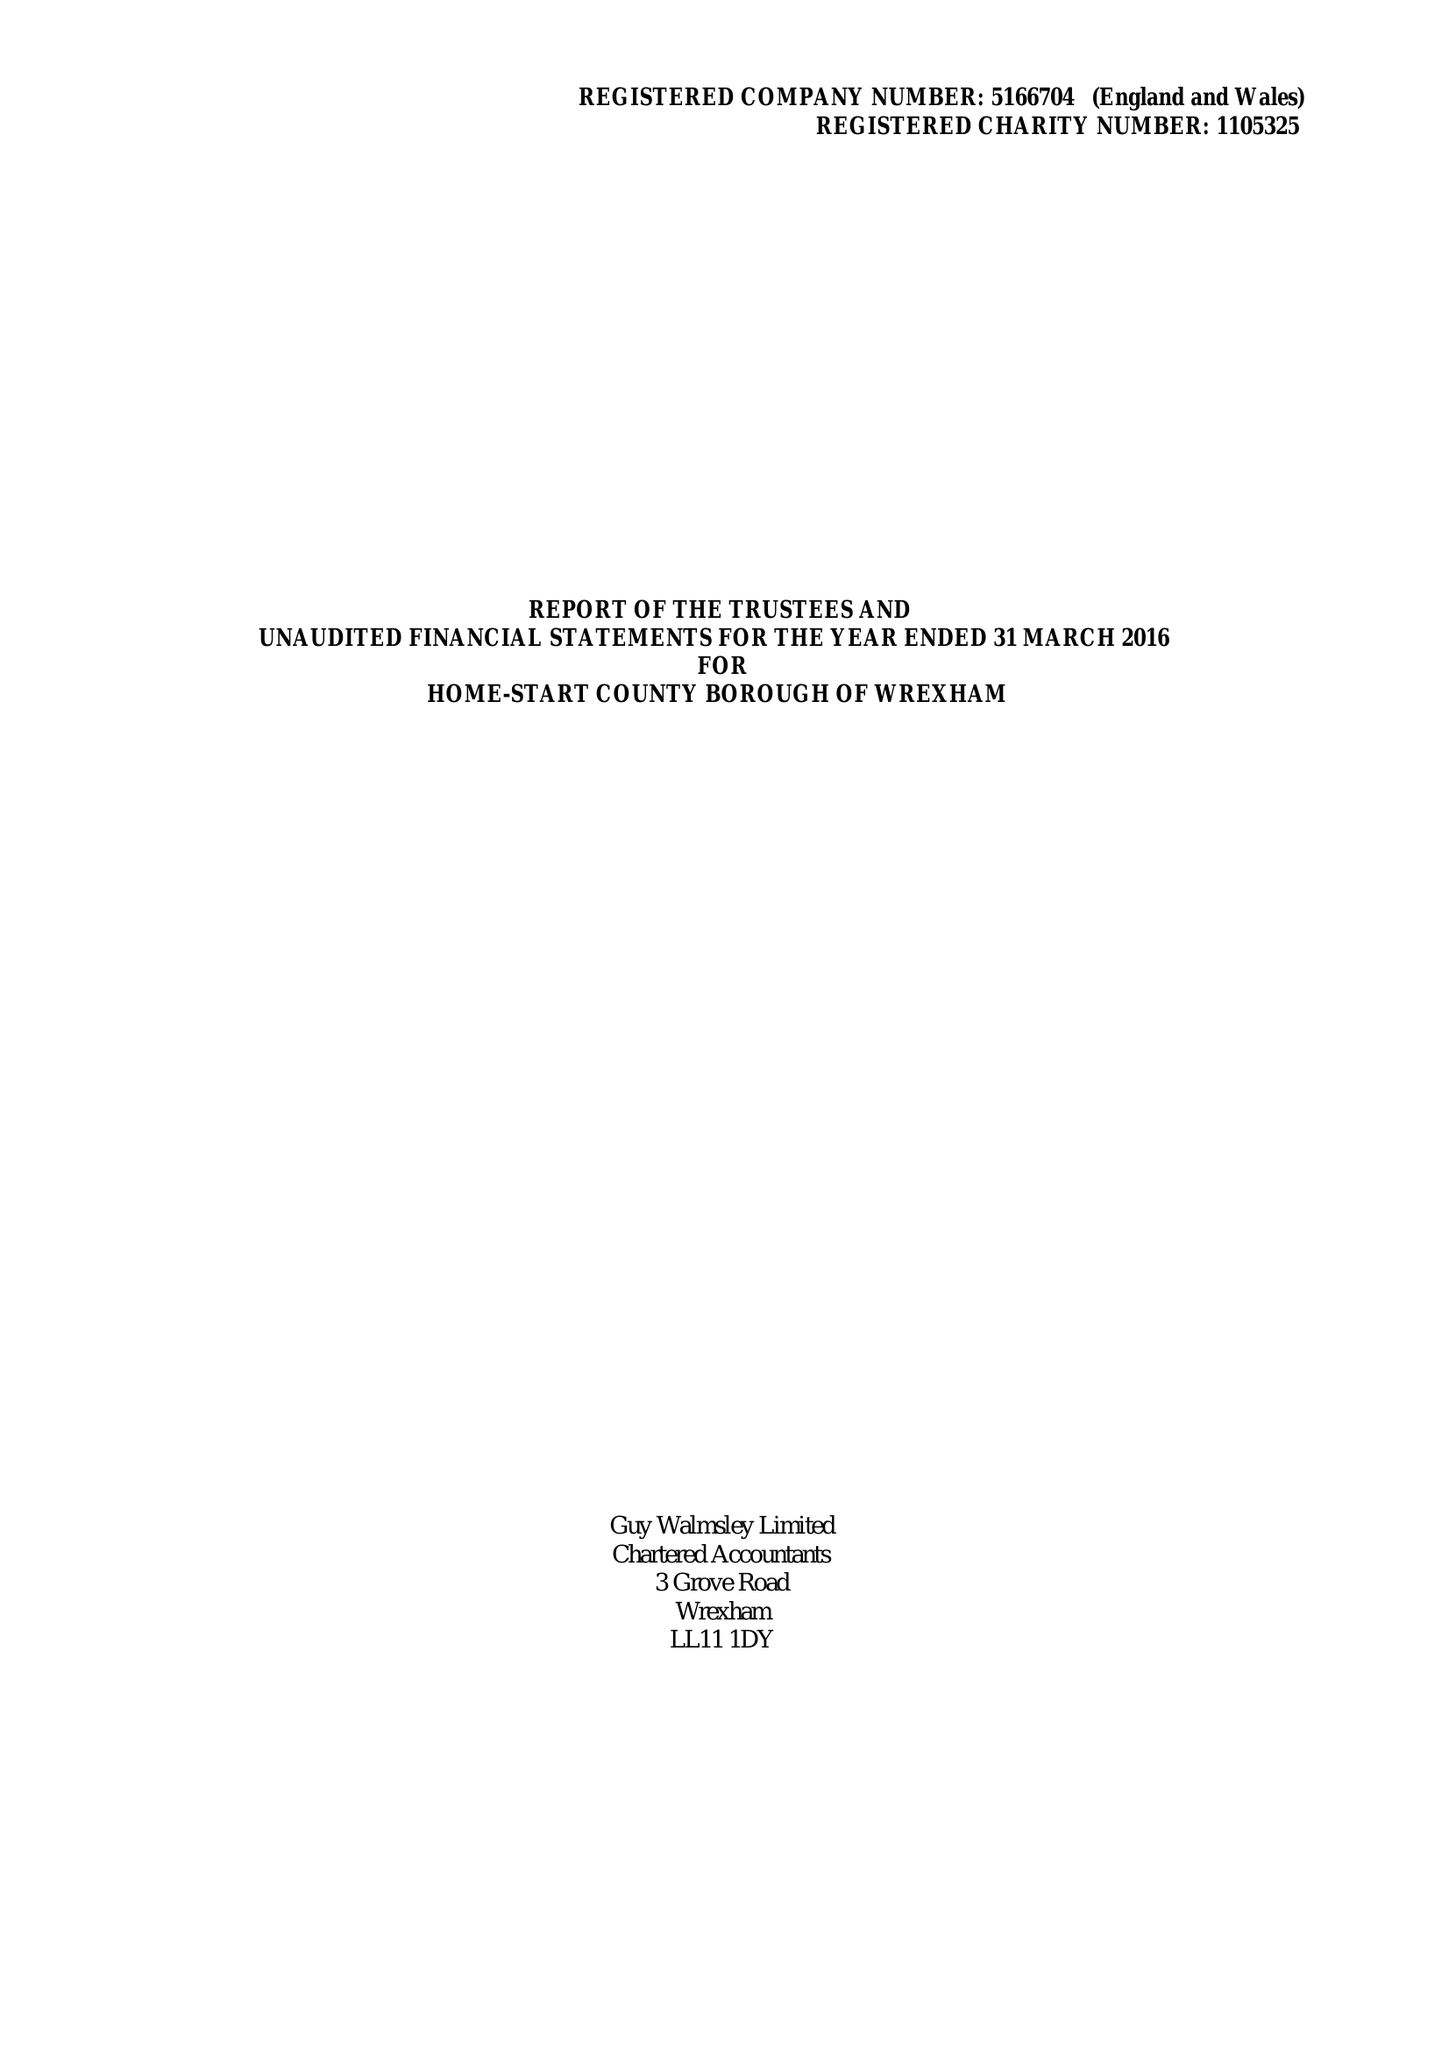What is the value for the charity_name?
Answer the question using a single word or phrase. Home-Start County Borough Of Wrexham 